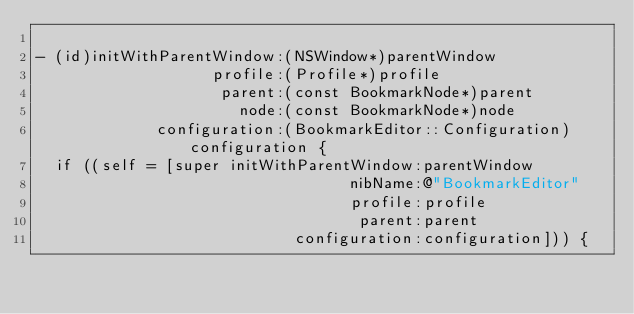Convert code to text. <code><loc_0><loc_0><loc_500><loc_500><_ObjectiveC_>
- (id)initWithParentWindow:(NSWindow*)parentWindow
                   profile:(Profile*)profile
                    parent:(const BookmarkNode*)parent
                      node:(const BookmarkNode*)node
             configuration:(BookmarkEditor::Configuration)configuration {
  if ((self = [super initWithParentWindow:parentWindow
                                  nibName:@"BookmarkEditor"
                                  profile:profile
                                   parent:parent
                            configuration:configuration])) {</code> 